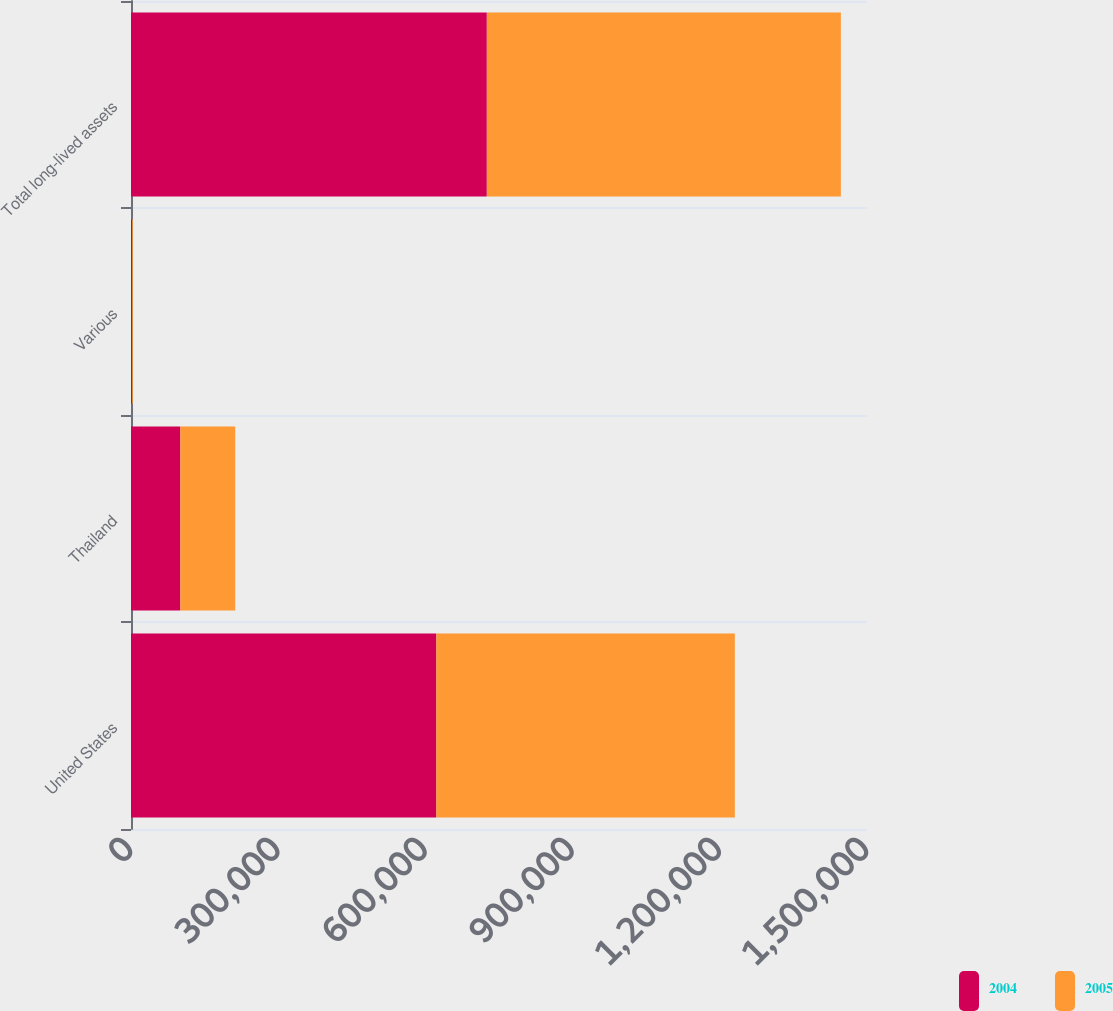<chart> <loc_0><loc_0><loc_500><loc_500><stacked_bar_chart><ecel><fcel>United States<fcel>Thailand<fcel>Various<fcel>Total long-lived assets<nl><fcel>2004<fcel>622287<fcel>100622<fcel>2279<fcel>725188<nl><fcel>2005<fcel>608343<fcel>111730<fcel>1479<fcel>721552<nl></chart> 